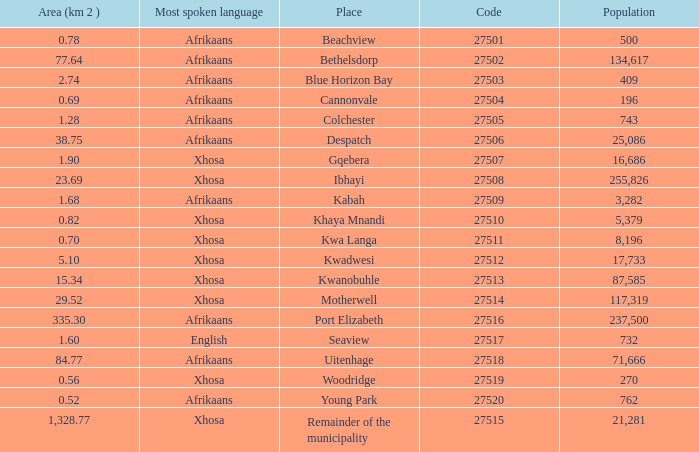Could you parse the entire table? {'header': ['Area (km 2 )', 'Most spoken language', 'Place', 'Code', 'Population'], 'rows': [['0.78', 'Afrikaans', 'Beachview', '27501', '500'], ['77.64', 'Afrikaans', 'Bethelsdorp', '27502', '134,617'], ['2.74', 'Afrikaans', 'Blue Horizon Bay', '27503', '409'], ['0.69', 'Afrikaans', 'Cannonvale', '27504', '196'], ['1.28', 'Afrikaans', 'Colchester', '27505', '743'], ['38.75', 'Afrikaans', 'Despatch', '27506', '25,086'], ['1.90', 'Xhosa', 'Gqebera', '27507', '16,686'], ['23.69', 'Xhosa', 'Ibhayi', '27508', '255,826'], ['1.68', 'Afrikaans', 'Kabah', '27509', '3,282'], ['0.82', 'Xhosa', 'Khaya Mnandi', '27510', '5,379'], ['0.70', 'Xhosa', 'Kwa Langa', '27511', '8,196'], ['5.10', 'Xhosa', 'Kwadwesi', '27512', '17,733'], ['15.34', 'Xhosa', 'Kwanobuhle', '27513', '87,585'], ['29.52', 'Xhosa', 'Motherwell', '27514', '117,319'], ['335.30', 'Afrikaans', 'Port Elizabeth', '27516', '237,500'], ['1.60', 'English', 'Seaview', '27517', '732'], ['84.77', 'Afrikaans', 'Uitenhage', '27518', '71,666'], ['0.56', 'Xhosa', 'Woodridge', '27519', '270'], ['0.52', 'Afrikaans', 'Young Park', '27520', '762'], ['1,328.77', 'Xhosa', 'Remainder of the municipality', '27515', '21,281']]} What is the total code number for places with a population greater than 87,585? 4.0. 